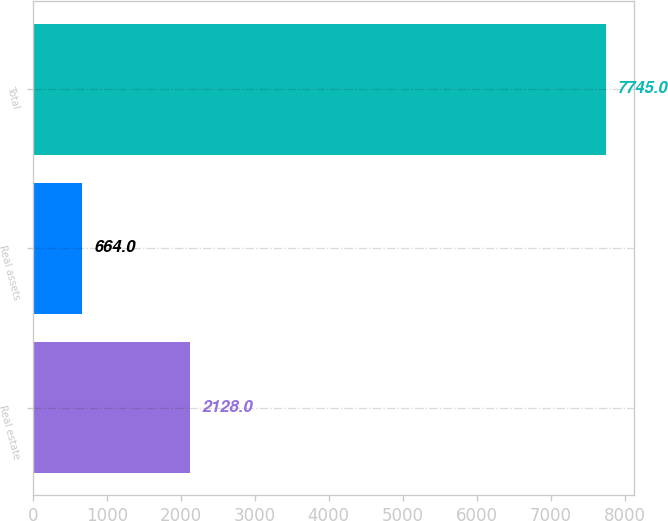<chart> <loc_0><loc_0><loc_500><loc_500><bar_chart><fcel>Real estate<fcel>Real assets<fcel>Total<nl><fcel>2128<fcel>664<fcel>7745<nl></chart> 